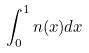<formula> <loc_0><loc_0><loc_500><loc_500>\int _ { 0 } ^ { 1 } n ( x ) d x</formula> 